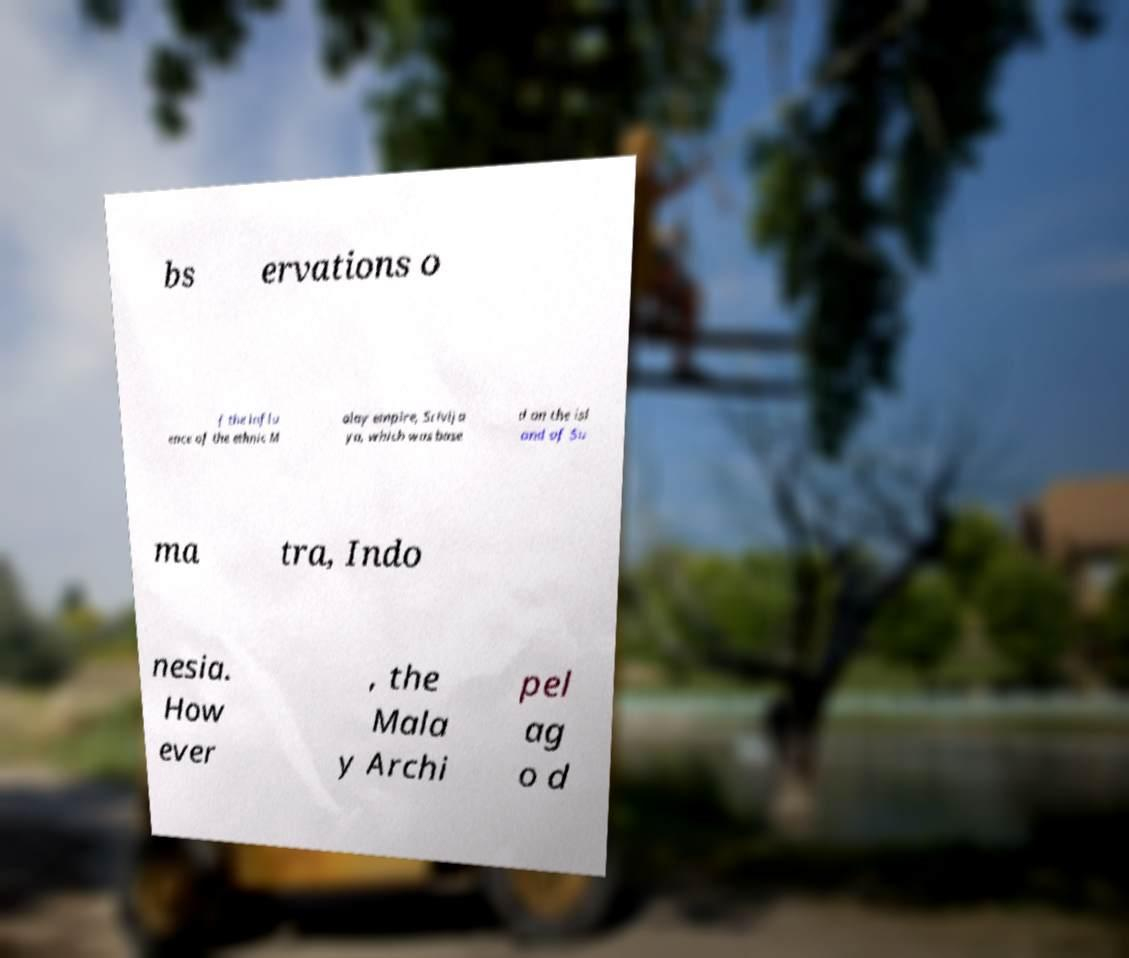Could you assist in decoding the text presented in this image and type it out clearly? bs ervations o f the influ ence of the ethnic M alay empire, Srivija ya, which was base d on the isl and of Su ma tra, Indo nesia. How ever , the Mala y Archi pel ag o d 